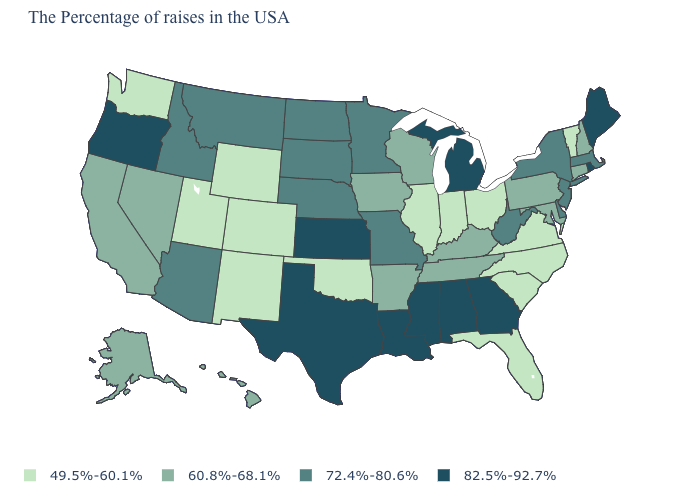What is the value of Texas?
Short answer required. 82.5%-92.7%. What is the highest value in the MidWest ?
Quick response, please. 82.5%-92.7%. What is the value of Maine?
Keep it brief. 82.5%-92.7%. What is the value of Connecticut?
Short answer required. 60.8%-68.1%. What is the value of West Virginia?
Give a very brief answer. 72.4%-80.6%. What is the value of Louisiana?
Concise answer only. 82.5%-92.7%. Name the states that have a value in the range 49.5%-60.1%?
Give a very brief answer. Vermont, Virginia, North Carolina, South Carolina, Ohio, Florida, Indiana, Illinois, Oklahoma, Wyoming, Colorado, New Mexico, Utah, Washington. What is the value of Oklahoma?
Keep it brief. 49.5%-60.1%. Among the states that border California , does Oregon have the lowest value?
Quick response, please. No. Name the states that have a value in the range 49.5%-60.1%?
Give a very brief answer. Vermont, Virginia, North Carolina, South Carolina, Ohio, Florida, Indiana, Illinois, Oklahoma, Wyoming, Colorado, New Mexico, Utah, Washington. Name the states that have a value in the range 82.5%-92.7%?
Concise answer only. Maine, Rhode Island, Georgia, Michigan, Alabama, Mississippi, Louisiana, Kansas, Texas, Oregon. Does Missouri have the highest value in the USA?
Keep it brief. No. Does Vermont have the same value as Connecticut?
Concise answer only. No. Among the states that border Idaho , which have the lowest value?
Answer briefly. Wyoming, Utah, Washington. Which states have the lowest value in the USA?
Keep it brief. Vermont, Virginia, North Carolina, South Carolina, Ohio, Florida, Indiana, Illinois, Oklahoma, Wyoming, Colorado, New Mexico, Utah, Washington. 